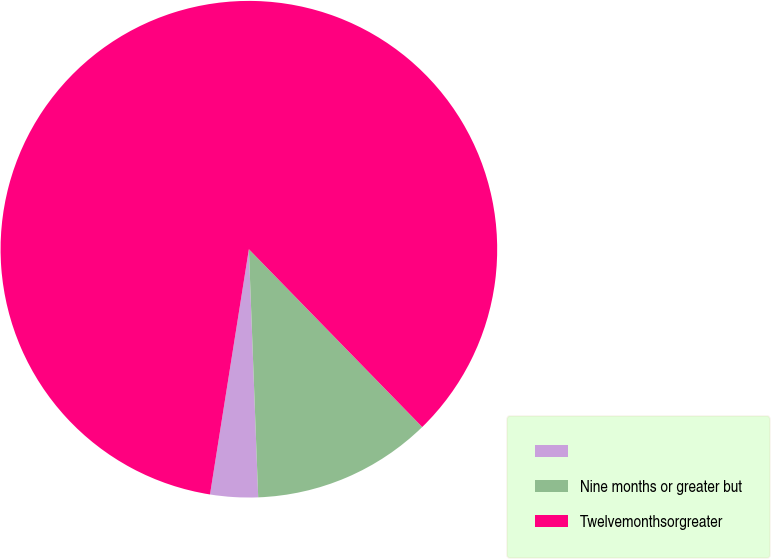Convert chart. <chart><loc_0><loc_0><loc_500><loc_500><pie_chart><ecel><fcel>Nine months or greater but<fcel>Twelvemonthsorgreater<nl><fcel>3.1%<fcel>11.7%<fcel>85.2%<nl></chart> 